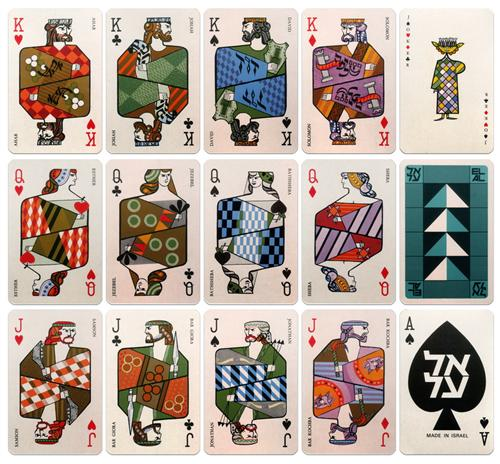Can you describe how the style of these cards reflects the mid-century modern art movement? Certainly! Mid-century modern art is known for its clean lines, geometric shapes, and vibrant color palettes, all of which are vividly reflected in the playing cards. The design of these cards utilizes a minimalistic yet bold approach typical of the era, focusing on functional beauty and visual accessibility. The combination of sharp angles and smooth curves, along with the judicious use of contrasting colors, embodies the movement’s ideals of breaking away from the ornate designs of earlier periods to embrace simplicity and modernity. This stylistic choice not only makes the cards strikingly attractive but also mirrors broader societal shifts toward more simplified and visually clear design philosophies during the mid-20th century. 